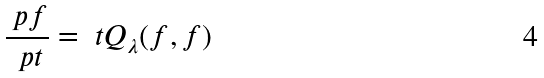Convert formula to latex. <formula><loc_0><loc_0><loc_500><loc_500>\frac { \ p f } { \ p t } = \ t Q _ { \lambda } ( f , f )</formula> 